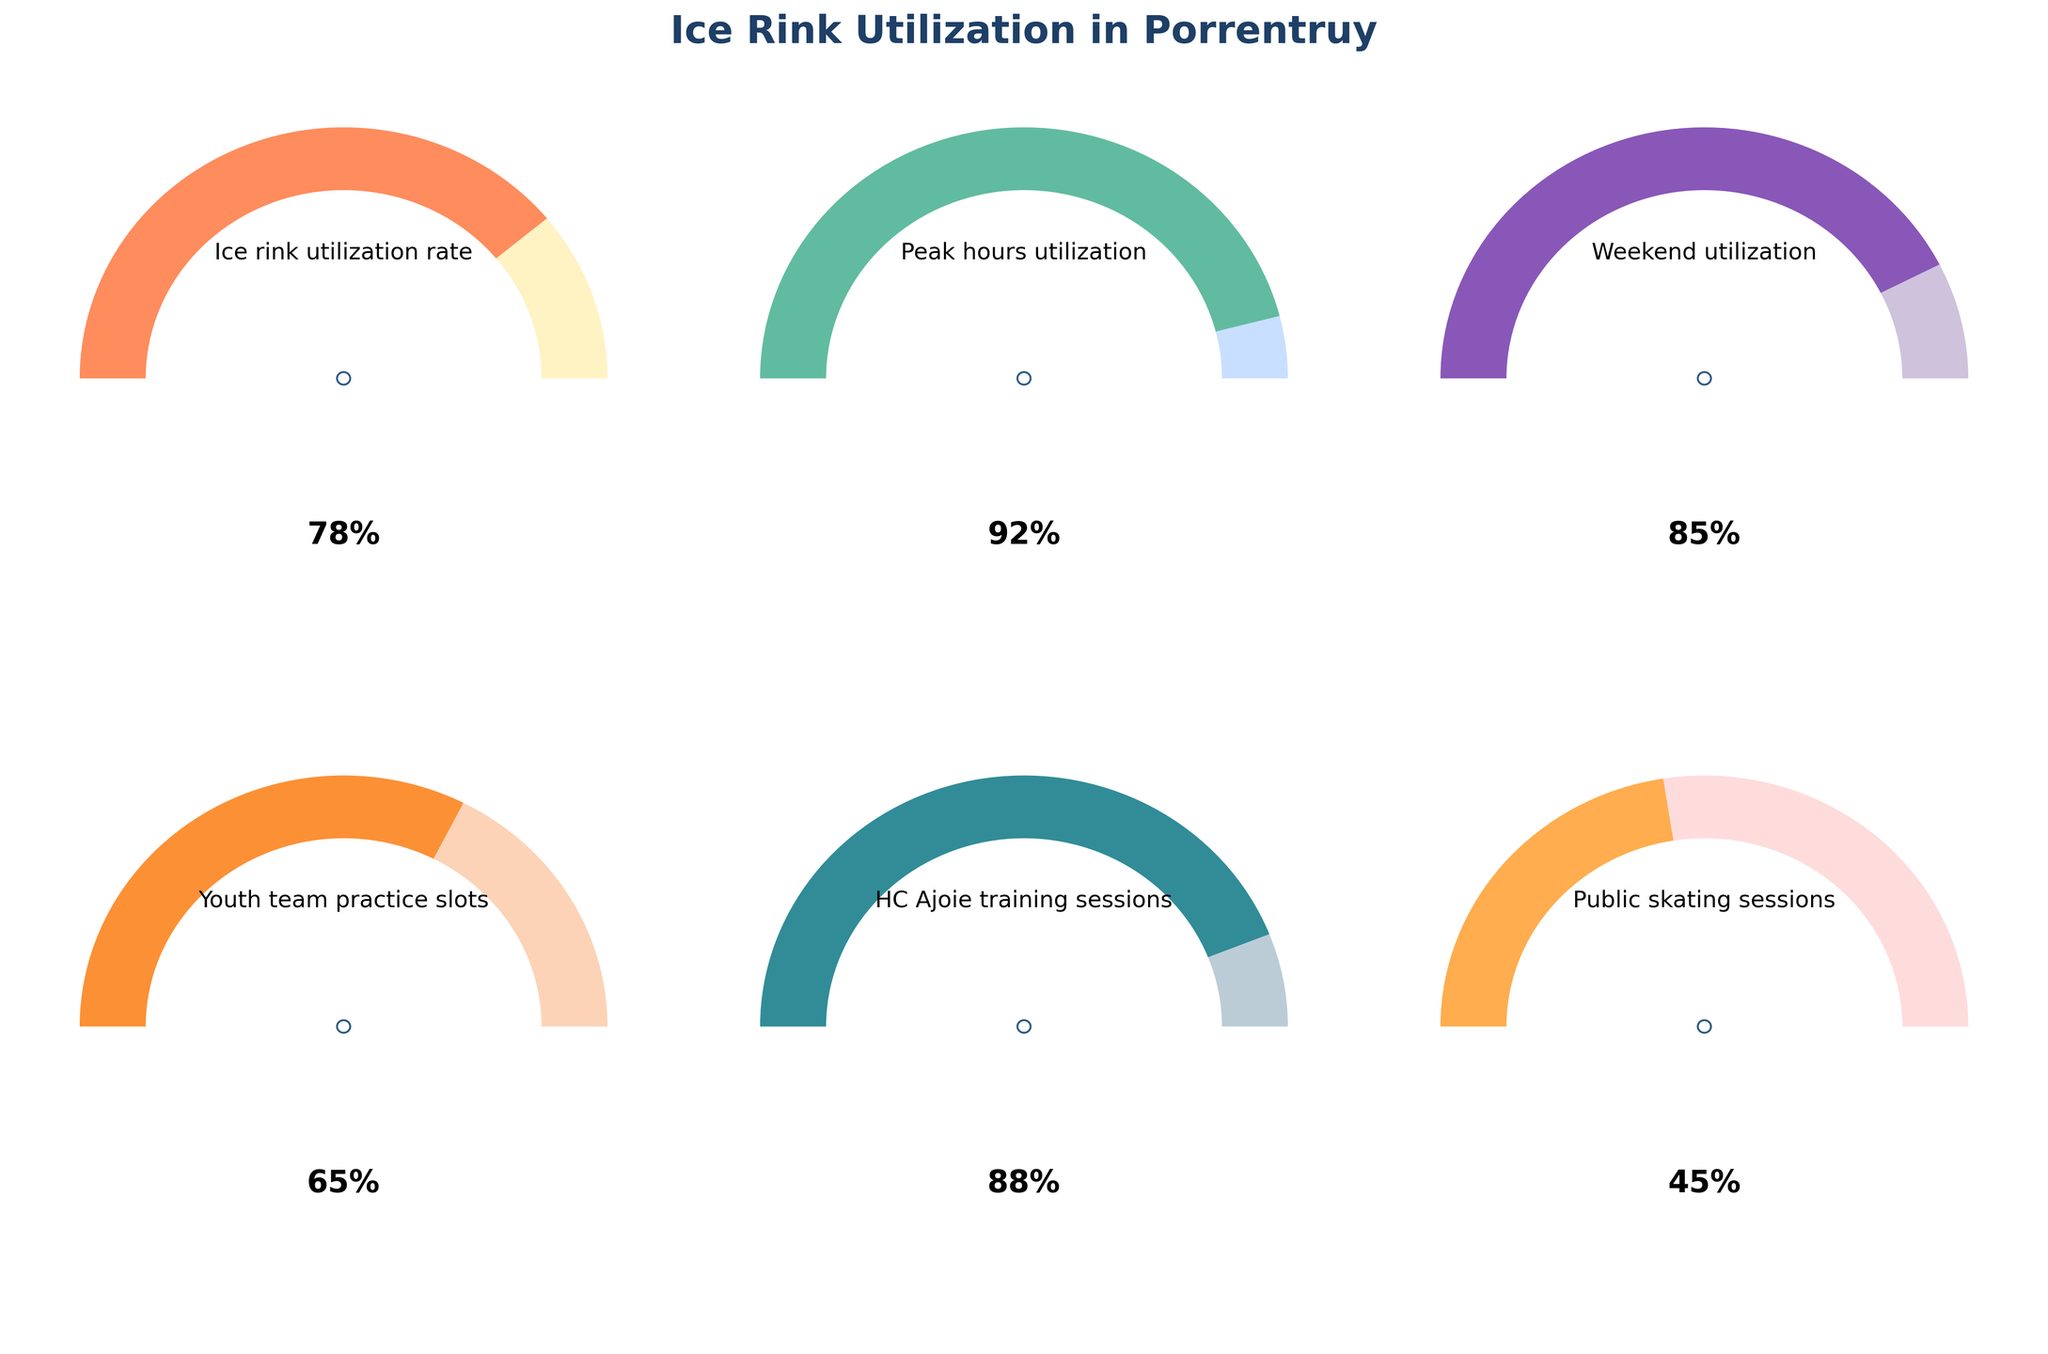What is the utilization rate of the ice rink during peak hours? The figure shows that the utilization rate is displayed on one of the gauge charts. The title for this gauge indicates "Peak hours utilization" with a value of 92%.
Answer: 92% Which gauge has the lowest utilization rate? By comparing the values of all the gauges, the "Public skating sessions" gauge shows the lowest utilization rate at 45%.
Answer: Public skating sessions What is the difference in utilization rate between HC Ajoie training sessions and youth team practice slots? The value for HC Ajoie training sessions is 88%, and for youth team practice slots, it is 65%. The difference is 88% - 65% = 23%.
Answer: 23% Which utilization rate is higher: weekends or public skating sessions? The "Weekend utilization" gauge shows 85%, whereas the "Public skating sessions" gauge shows 45%. Hence, the weekend utilization rate is higher.
Answer: Weekends What is the average utilization rate of all gauges? The values for the utilization rates are 78%, 92%, 85%, 65%, 88%, and 45%. The average is calculated as (78 + 92 + 85 + 65 + 88 + 45) / 6 = 75.5%.
Answer: 75.5% Which gauge indicates a utilization rate below 50%? The only gauge showing a utilization rate below 50% is "Public skating sessions" with a rate of 45%.
Answer: Public skating sessions How much higher is the peak hours utilization rate compared to the overall ice rink utilization rate? The peak hours utilization rate is 92%, and the overall ice rink utilization rate is 78%. The difference is 92% - 78% = 14%.
Answer: 14% Is the HC Ajoie training sessions utilization rate greater than the weekend utilization rate? The HC Ajoie training sessions utilization rate is 88%, and the weekend utilization rate is 85%. Therefore, HC Ajoie's rate is greater.
Answer: Yes What is the median utilization rate among the given metrics? The sorted utilization rates are 45%, 65%, 78%, 85%, 88%, 92%. The median is the average of the middle two values ((78+85)/2) which equals 81.5%.
Answer: 81.5% Is the youth team practice slots utilization rate more than half of the peak hours utilization rate? Half of the peak hours utilization rate is 92% / 2 = 46%. The youth team practice slots utilization rate is 65%, which is greater than 46%.
Answer: Yes 